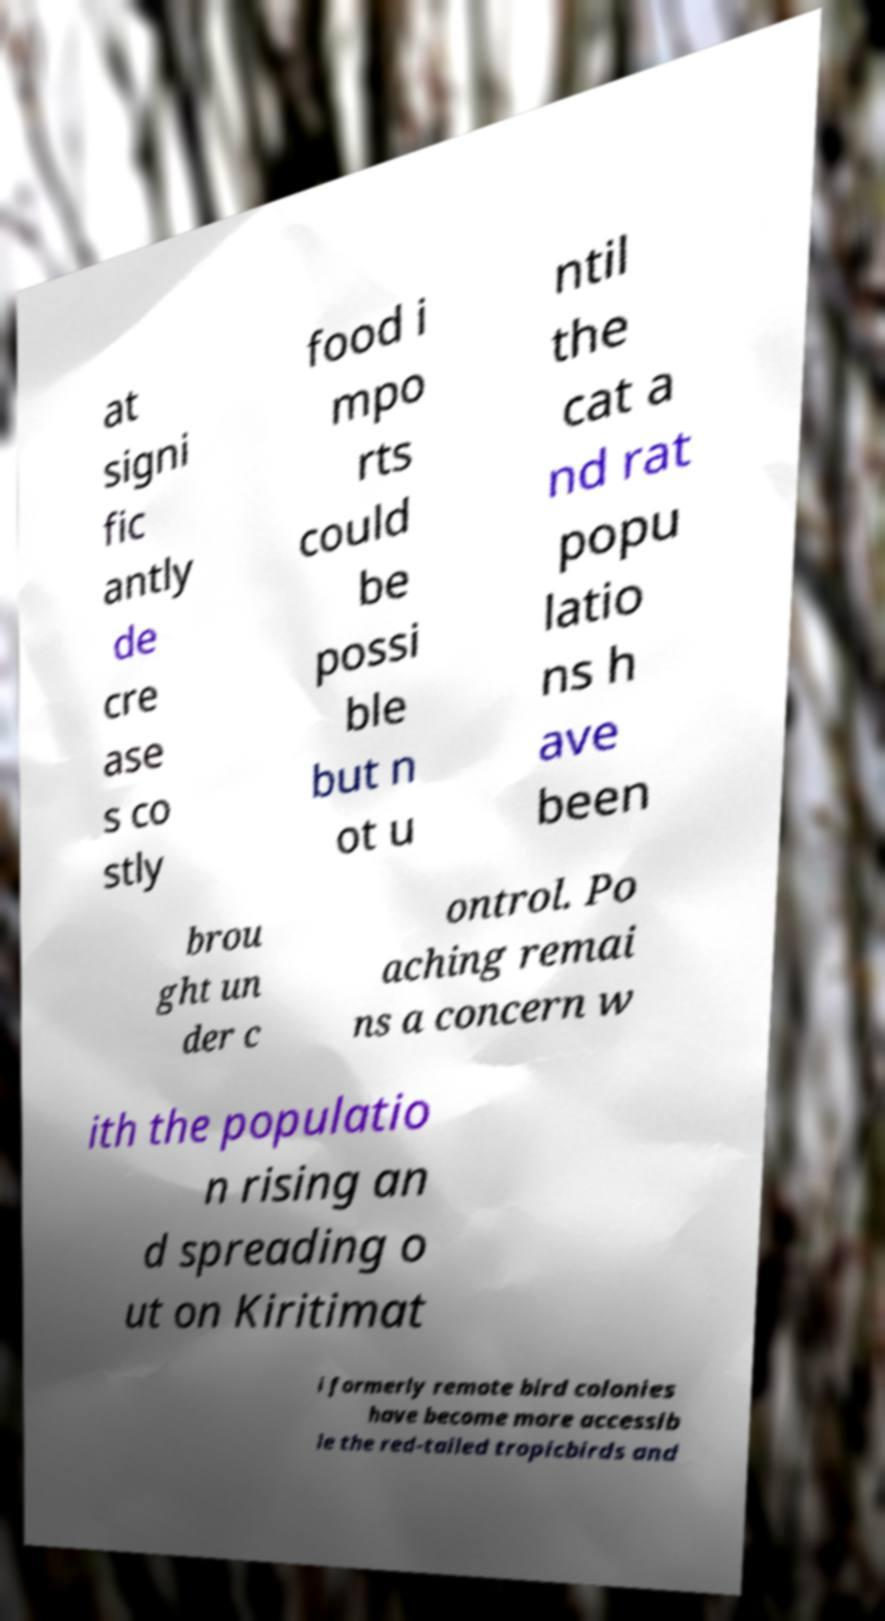Can you accurately transcribe the text from the provided image for me? at signi fic antly de cre ase s co stly food i mpo rts could be possi ble but n ot u ntil the cat a nd rat popu latio ns h ave been brou ght un der c ontrol. Po aching remai ns a concern w ith the populatio n rising an d spreading o ut on Kiritimat i formerly remote bird colonies have become more accessib le the red-tailed tropicbirds and 